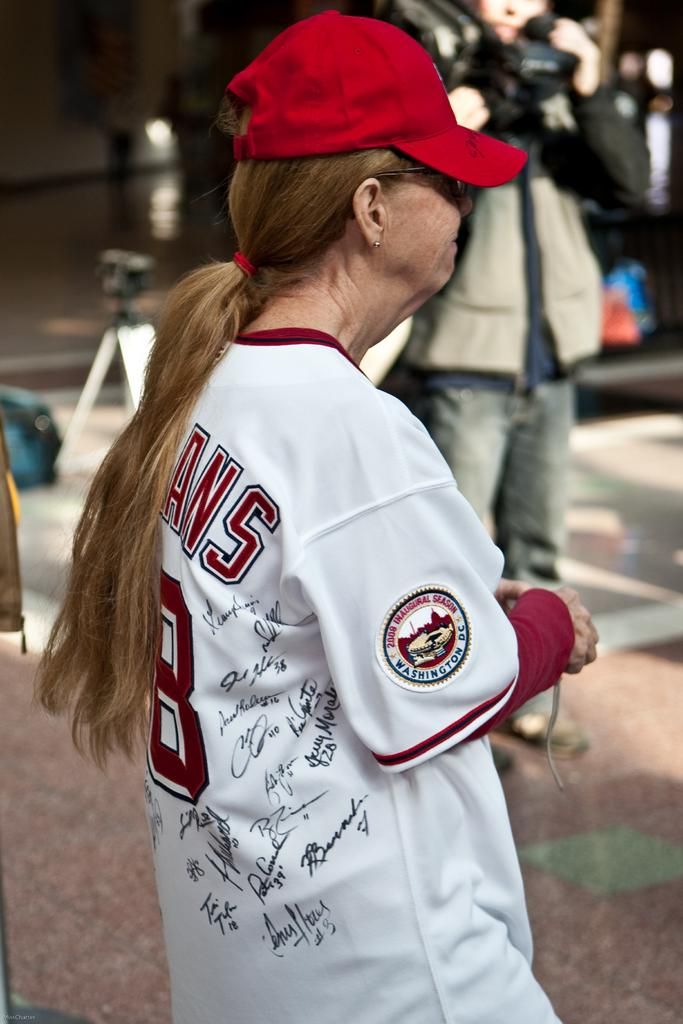<image>
Give a short and clear explanation of the subsequent image. A woman in a baseball cap and a signed jersey that is number 8. 